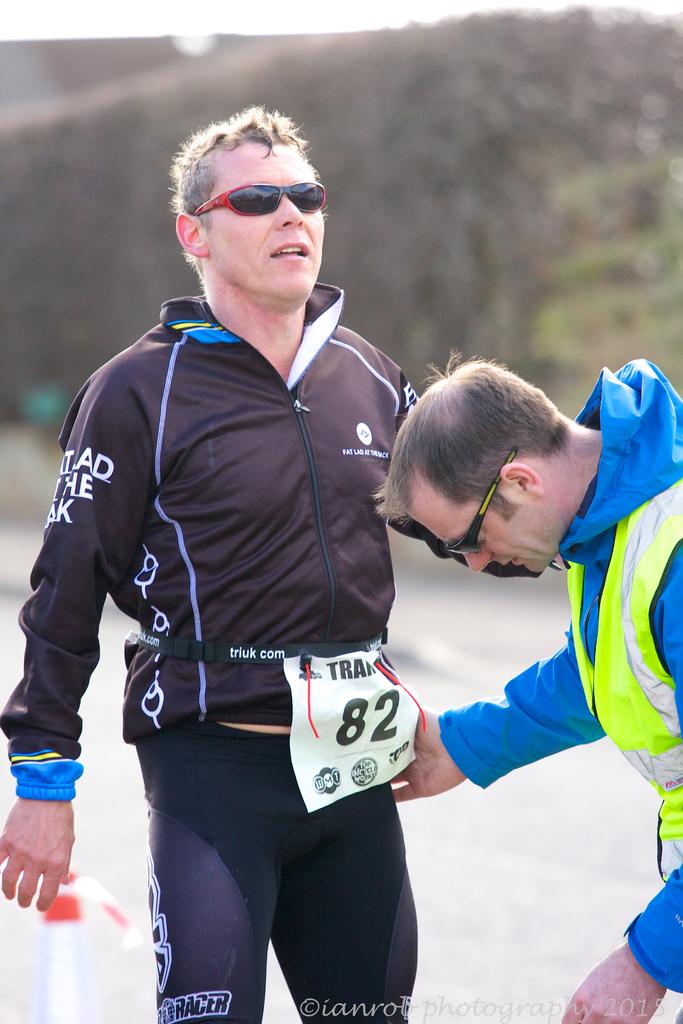What is the runner's number?
Provide a succinct answer. 82. 